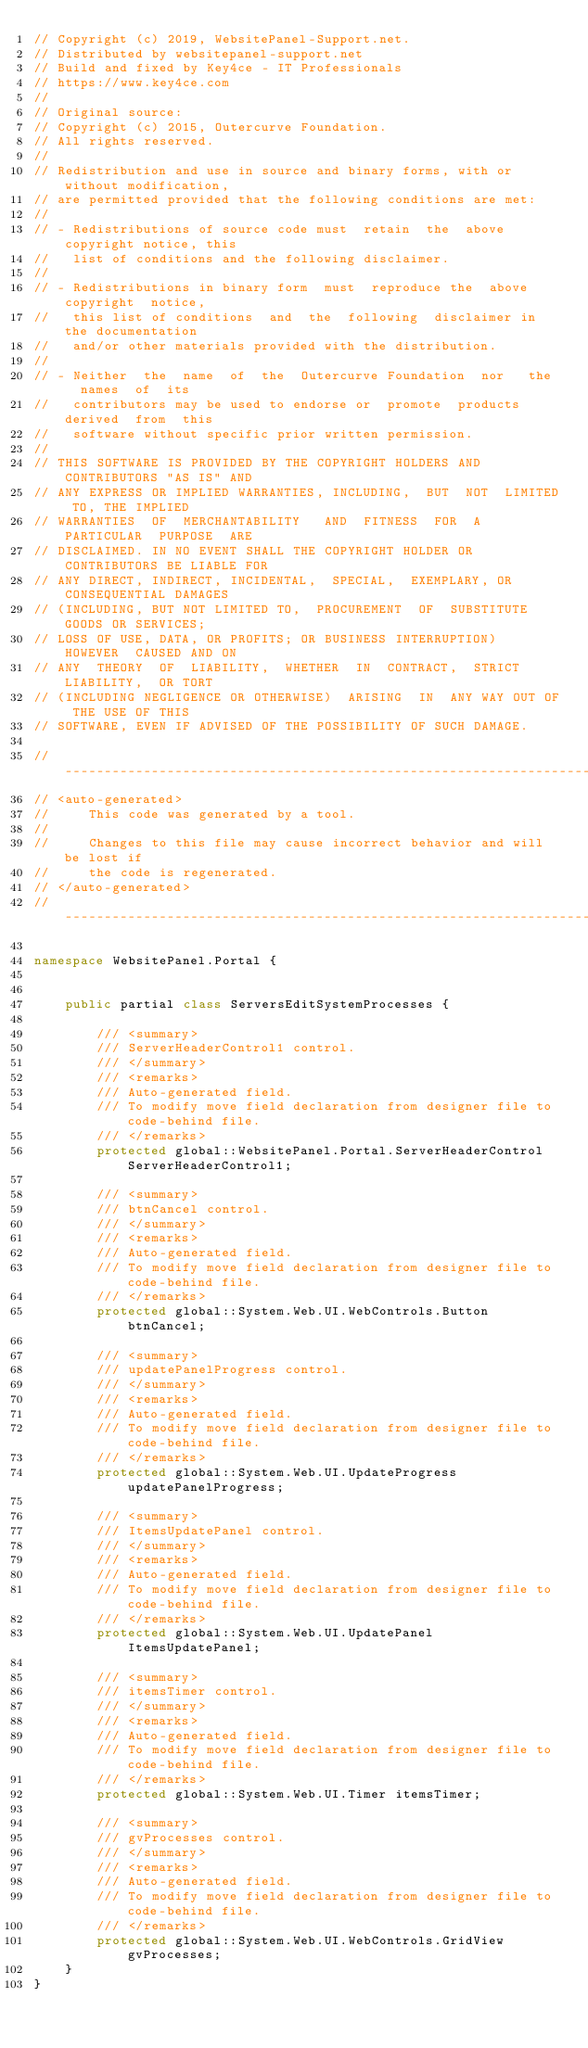Convert code to text. <code><loc_0><loc_0><loc_500><loc_500><_C#_>// Copyright (c) 2019, WebsitePanel-Support.net.
// Distributed by websitepanel-support.net
// Build and fixed by Key4ce - IT Professionals
// https://www.key4ce.com
// 
// Original source:
// Copyright (c) 2015, Outercurve Foundation.
// All rights reserved.
//
// Redistribution and use in source and binary forms, with or without modification,
// are permitted provided that the following conditions are met:
//
// - Redistributions of source code must  retain  the  above copyright notice, this
//   list of conditions and the following disclaimer.
//
// - Redistributions in binary form  must  reproduce the  above  copyright  notice,
//   this list of conditions  and  the  following  disclaimer in  the documentation
//   and/or other materials provided with the distribution.
//
// - Neither  the  name  of  the  Outercurve Foundation  nor   the   names  of  its
//   contributors may be used to endorse or  promote  products  derived  from  this
//   software without specific prior written permission.
//
// THIS SOFTWARE IS PROVIDED BY THE COPYRIGHT HOLDERS AND CONTRIBUTORS "AS IS" AND
// ANY EXPRESS OR IMPLIED WARRANTIES, INCLUDING,  BUT  NOT  LIMITED TO, THE IMPLIED
// WARRANTIES  OF  MERCHANTABILITY   AND  FITNESS  FOR  A  PARTICULAR  PURPOSE  ARE
// DISCLAIMED. IN NO EVENT SHALL THE COPYRIGHT HOLDER OR CONTRIBUTORS BE LIABLE FOR
// ANY DIRECT, INDIRECT, INCIDENTAL,  SPECIAL,  EXEMPLARY, OR CONSEQUENTIAL DAMAGES
// (INCLUDING, BUT NOT LIMITED TO,  PROCUREMENT  OF  SUBSTITUTE  GOODS OR SERVICES;
// LOSS OF USE, DATA, OR PROFITS; OR BUSINESS INTERRUPTION)  HOWEVER  CAUSED AND ON
// ANY  THEORY  OF  LIABILITY,  WHETHER  IN  CONTRACT,  STRICT  LIABILITY,  OR TORT
// (INCLUDING NEGLIGENCE OR OTHERWISE)  ARISING  IN  ANY WAY OUT OF THE USE OF THIS
// SOFTWARE, EVEN IF ADVISED OF THE POSSIBILITY OF SUCH DAMAGE.

//------------------------------------------------------------------------------
// <auto-generated>
//     This code was generated by a tool.
//
//     Changes to this file may cause incorrect behavior and will be lost if
//     the code is regenerated. 
// </auto-generated>
//------------------------------------------------------------------------------

namespace WebsitePanel.Portal {
    
    
    public partial class ServersEditSystemProcesses {
        
        /// <summary>
        /// ServerHeaderControl1 control.
        /// </summary>
        /// <remarks>
        /// Auto-generated field.
        /// To modify move field declaration from designer file to code-behind file.
        /// </remarks>
        protected global::WebsitePanel.Portal.ServerHeaderControl ServerHeaderControl1;
        
        /// <summary>
        /// btnCancel control.
        /// </summary>
        /// <remarks>
        /// Auto-generated field.
        /// To modify move field declaration from designer file to code-behind file.
        /// </remarks>
        protected global::System.Web.UI.WebControls.Button btnCancel;
        
        /// <summary>
        /// updatePanelProgress control.
        /// </summary>
        /// <remarks>
        /// Auto-generated field.
        /// To modify move field declaration from designer file to code-behind file.
        /// </remarks>
        protected global::System.Web.UI.UpdateProgress updatePanelProgress;
        
        /// <summary>
        /// ItemsUpdatePanel control.
        /// </summary>
        /// <remarks>
        /// Auto-generated field.
        /// To modify move field declaration from designer file to code-behind file.
        /// </remarks>
        protected global::System.Web.UI.UpdatePanel ItemsUpdatePanel;
        
        /// <summary>
        /// itemsTimer control.
        /// </summary>
        /// <remarks>
        /// Auto-generated field.
        /// To modify move field declaration from designer file to code-behind file.
        /// </remarks>
        protected global::System.Web.UI.Timer itemsTimer;
        
        /// <summary>
        /// gvProcesses control.
        /// </summary>
        /// <remarks>
        /// Auto-generated field.
        /// To modify move field declaration from designer file to code-behind file.
        /// </remarks>
        protected global::System.Web.UI.WebControls.GridView gvProcesses;
    }
}
</code> 